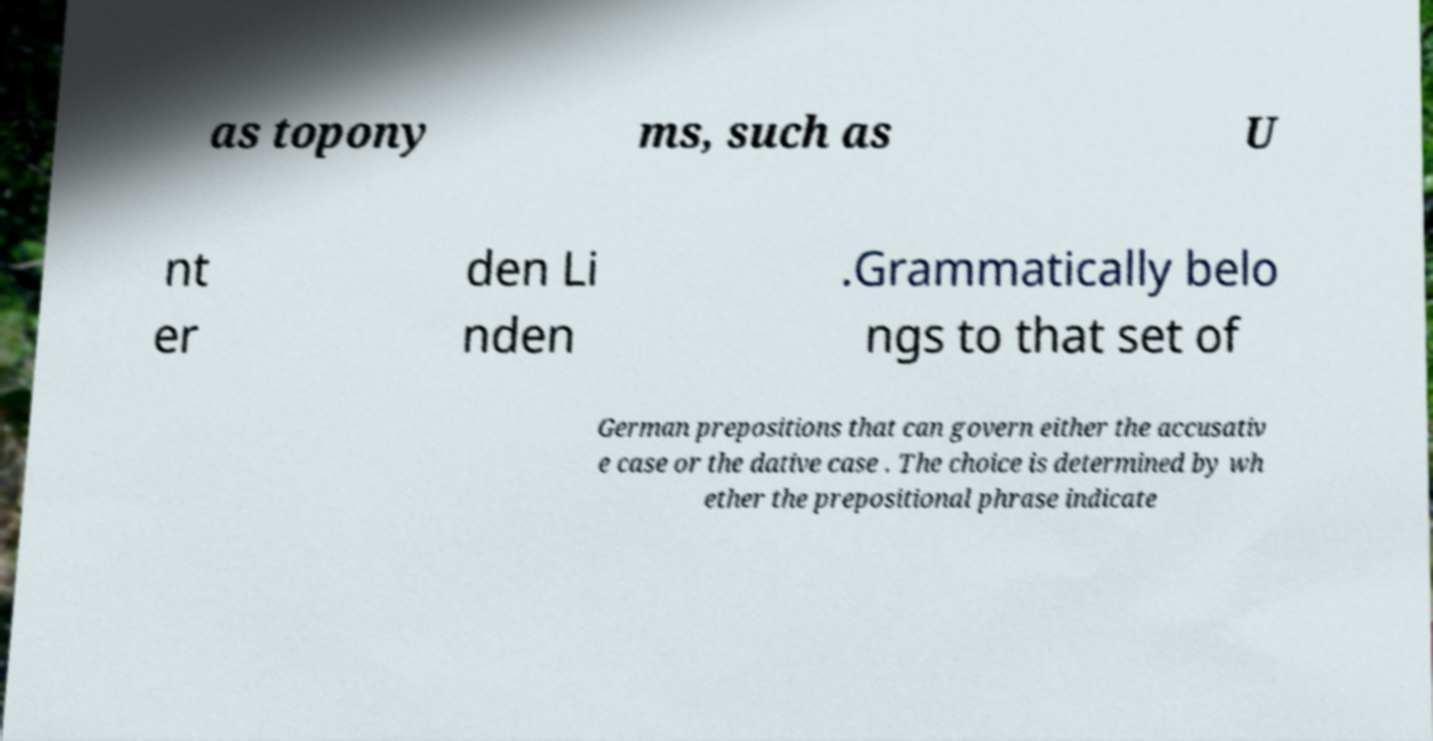Please identify and transcribe the text found in this image. as topony ms, such as U nt er den Li nden .Grammatically belo ngs to that set of German prepositions that can govern either the accusativ e case or the dative case . The choice is determined by wh ether the prepositional phrase indicate 